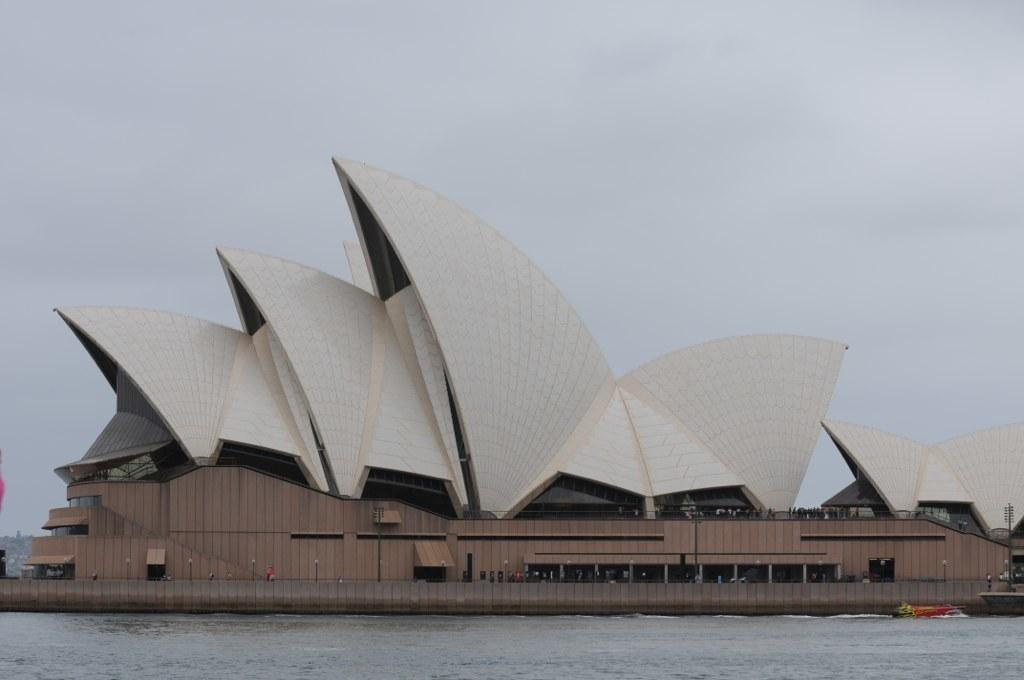What type of structure is present in the image? There is a building in the image. What natural element can be seen in the image? There is water visible in the image. What object is located on the right side of the image? There is a pole on the right side of the image. What is visible in the background of the image? The sky is visible in the background of the image. What type of thread is being used to sew the apparel in the image? There is no apparel or thread present in the image. What type of meal is being prepared in the image? There is no meal preparation visible in the image. 